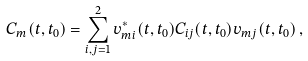<formula> <loc_0><loc_0><loc_500><loc_500>C _ { m } ( t , t _ { 0 } ) = \sum _ { i , j = 1 } ^ { 2 } v _ { m i } ^ { \ast } ( t , t _ { 0 } ) C _ { i j } ( t , t _ { 0 } ) v _ { m j } ( t , t _ { 0 } ) \, ,</formula> 